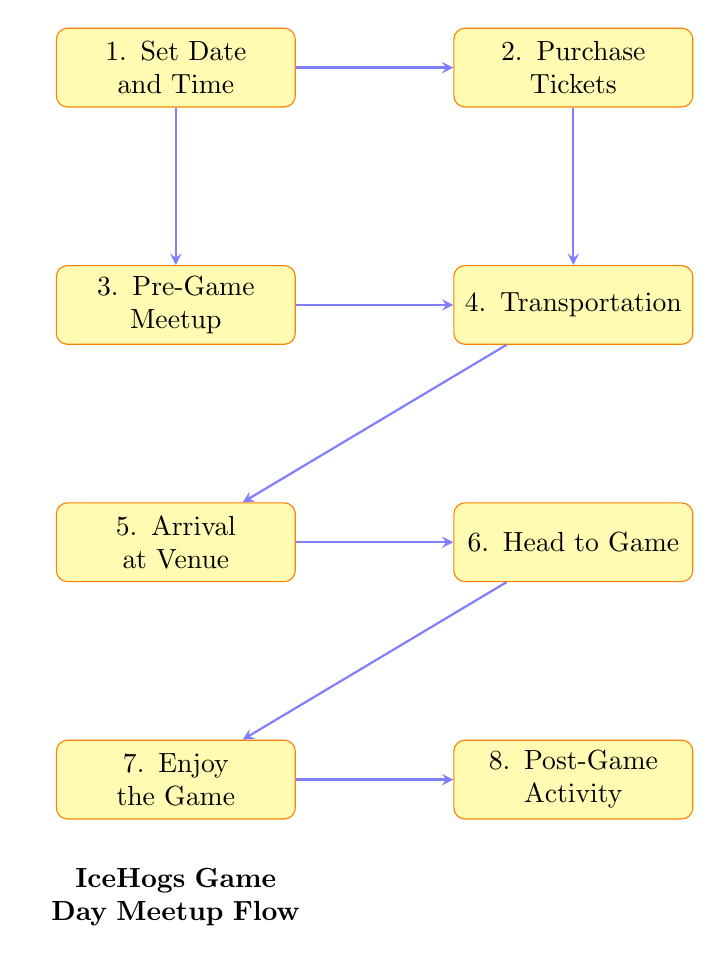What is the first step in the game day meetup? The diagram shows that the first step is "Set Date and Time". This node is positioned at the top, indicating it is the starting point of the flow.
Answer: Set Date and Time How many main tasks are outlined in the flow chart? The diagram outlines a total of eight main tasks, each represented as a node in the flow chart. Counting them confirms that there are eight tasks.
Answer: 8 What task follows "Purchase Tickets"? Looking at the flow, the arrow directs us to the next task after "Purchase Tickets", which is "Transportation". This indicates the order in which the tasks should be completed.
Answer: Transportation What is the final activity planned after "Enjoy the Game"? The last task in the flow can be seen directly below "Enjoy the Game". The arrow leads to "Post-Game Activity", indicating this is what comes after the game.
Answer: Post-Game Activity What venues are mentioned for the Pre-Game Meetup? In the "Pre-Game Meetup" task description, two venues are specified: "Owly Oop Sports Pub" and "Vintage @ 501". These are the options presented for the meetup.
Answer: Owly Oop Sports Pub, Vintage @ 501 What task requires coordinating ticket purchases? In the flow, the task titled "Purchase Tickets" indicates a need for coordination to ensure the group sits together. It highlights the group's preparation for attending the game.
Answer: Purchase Tickets How does the transportation task connect to the Pre-Game Meetup? The diagram shows that the "Transportation" task follows both "Purchase Tickets" and "Pre-Game Meetup". This indicates that transportation arrangements are made in conjunction with the pre-game plans.
Answer: There are two paths leading to Transportation What is the main focus of the "Enjoy the Game" task? The diagram clearly indicates that the task "Enjoy the Game" focuses on "Cheer and Support", which emphasizes wearing jerseys and cheering for the IceHogs.
Answer: Cheer and Support 